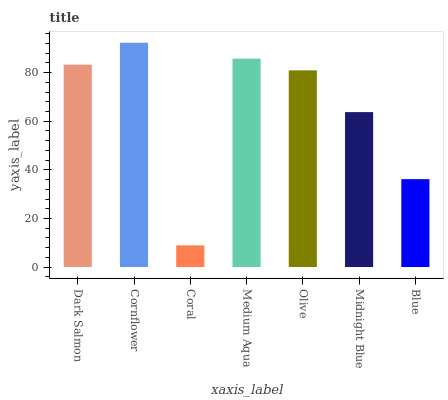Is Coral the minimum?
Answer yes or no. Yes. Is Cornflower the maximum?
Answer yes or no. Yes. Is Cornflower the minimum?
Answer yes or no. No. Is Coral the maximum?
Answer yes or no. No. Is Cornflower greater than Coral?
Answer yes or no. Yes. Is Coral less than Cornflower?
Answer yes or no. Yes. Is Coral greater than Cornflower?
Answer yes or no. No. Is Cornflower less than Coral?
Answer yes or no. No. Is Olive the high median?
Answer yes or no. Yes. Is Olive the low median?
Answer yes or no. Yes. Is Midnight Blue the high median?
Answer yes or no. No. Is Cornflower the low median?
Answer yes or no. No. 